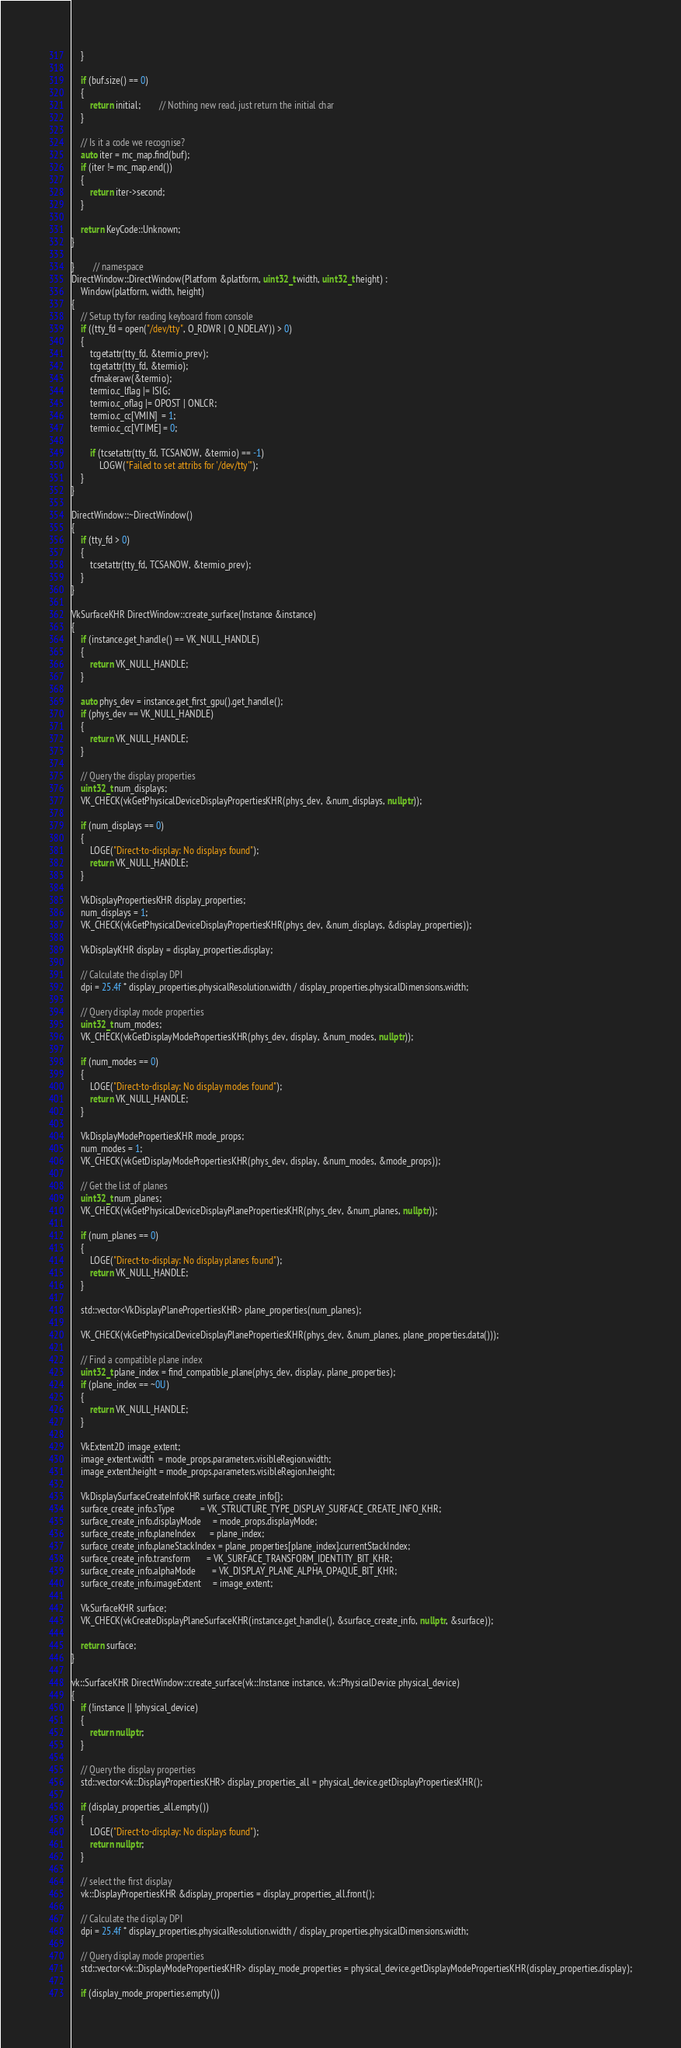Convert code to text. <code><loc_0><loc_0><loc_500><loc_500><_C++_>	}

	if (buf.size() == 0)
	{
		return initial;        // Nothing new read, just return the initial char
	}

	// Is it a code we recognise?
	auto iter = mc_map.find(buf);
	if (iter != mc_map.end())
	{
		return iter->second;
	}

	return KeyCode::Unknown;
}

}        // namespace
DirectWindow::DirectWindow(Platform &platform, uint32_t width, uint32_t height) :
    Window(platform, width, height)
{
	// Setup tty for reading keyboard from console
	if ((tty_fd = open("/dev/tty", O_RDWR | O_NDELAY)) > 0)
	{
		tcgetattr(tty_fd, &termio_prev);
		tcgetattr(tty_fd, &termio);
		cfmakeraw(&termio);
		termio.c_lflag |= ISIG;
		termio.c_oflag |= OPOST | ONLCR;
		termio.c_cc[VMIN]  = 1;
		termio.c_cc[VTIME] = 0;

		if (tcsetattr(tty_fd, TCSANOW, &termio) == -1)
			LOGW("Failed to set attribs for '/dev/tty'");
	}
}

DirectWindow::~DirectWindow()
{
	if (tty_fd > 0)
	{
		tcsetattr(tty_fd, TCSANOW, &termio_prev);
	}
}

VkSurfaceKHR DirectWindow::create_surface(Instance &instance)
{
	if (instance.get_handle() == VK_NULL_HANDLE)
	{
		return VK_NULL_HANDLE;
	}

	auto phys_dev = instance.get_first_gpu().get_handle();
	if (phys_dev == VK_NULL_HANDLE)
	{
		return VK_NULL_HANDLE;
	}

	// Query the display properties
	uint32_t num_displays;
	VK_CHECK(vkGetPhysicalDeviceDisplayPropertiesKHR(phys_dev, &num_displays, nullptr));

	if (num_displays == 0)
	{
		LOGE("Direct-to-display: No displays found");
		return VK_NULL_HANDLE;
	}

	VkDisplayPropertiesKHR display_properties;
	num_displays = 1;
	VK_CHECK(vkGetPhysicalDeviceDisplayPropertiesKHR(phys_dev, &num_displays, &display_properties));

	VkDisplayKHR display = display_properties.display;

	// Calculate the display DPI
	dpi = 25.4f * display_properties.physicalResolution.width / display_properties.physicalDimensions.width;

	// Query display mode properties
	uint32_t num_modes;
	VK_CHECK(vkGetDisplayModePropertiesKHR(phys_dev, display, &num_modes, nullptr));

	if (num_modes == 0)
	{
		LOGE("Direct-to-display: No display modes found");
		return VK_NULL_HANDLE;
	}

	VkDisplayModePropertiesKHR mode_props;
	num_modes = 1;
	VK_CHECK(vkGetDisplayModePropertiesKHR(phys_dev, display, &num_modes, &mode_props));

	// Get the list of planes
	uint32_t num_planes;
	VK_CHECK(vkGetPhysicalDeviceDisplayPlanePropertiesKHR(phys_dev, &num_planes, nullptr));

	if (num_planes == 0)
	{
		LOGE("Direct-to-display: No display planes found");
		return VK_NULL_HANDLE;
	}

	std::vector<VkDisplayPlanePropertiesKHR> plane_properties(num_planes);

	VK_CHECK(vkGetPhysicalDeviceDisplayPlanePropertiesKHR(phys_dev, &num_planes, plane_properties.data()));

	// Find a compatible plane index
	uint32_t plane_index = find_compatible_plane(phys_dev, display, plane_properties);
	if (plane_index == ~0U)
	{
		return VK_NULL_HANDLE;
	}

	VkExtent2D image_extent;
	image_extent.width  = mode_props.parameters.visibleRegion.width;
	image_extent.height = mode_props.parameters.visibleRegion.height;

	VkDisplaySurfaceCreateInfoKHR surface_create_info{};
	surface_create_info.sType           = VK_STRUCTURE_TYPE_DISPLAY_SURFACE_CREATE_INFO_KHR;
	surface_create_info.displayMode     = mode_props.displayMode;
	surface_create_info.planeIndex      = plane_index;
	surface_create_info.planeStackIndex = plane_properties[plane_index].currentStackIndex;
	surface_create_info.transform       = VK_SURFACE_TRANSFORM_IDENTITY_BIT_KHR;
	surface_create_info.alphaMode       = VK_DISPLAY_PLANE_ALPHA_OPAQUE_BIT_KHR;
	surface_create_info.imageExtent     = image_extent;

	VkSurfaceKHR surface;
	VK_CHECK(vkCreateDisplayPlaneSurfaceKHR(instance.get_handle(), &surface_create_info, nullptr, &surface));

	return surface;
}

vk::SurfaceKHR DirectWindow::create_surface(vk::Instance instance, vk::PhysicalDevice physical_device)
{
	if (!instance || !physical_device)
	{
		return nullptr;
	}

	// Query the display properties
	std::vector<vk::DisplayPropertiesKHR> display_properties_all = physical_device.getDisplayPropertiesKHR();

	if (display_properties_all.empty())
	{
		LOGE("Direct-to-display: No displays found");
		return nullptr;
	}

	// select the first display
	vk::DisplayPropertiesKHR &display_properties = display_properties_all.front();

	// Calculate the display DPI
	dpi = 25.4f * display_properties.physicalResolution.width / display_properties.physicalDimensions.width;

	// Query display mode properties
	std::vector<vk::DisplayModePropertiesKHR> display_mode_properties = physical_device.getDisplayModePropertiesKHR(display_properties.display);

	if (display_mode_properties.empty())</code> 